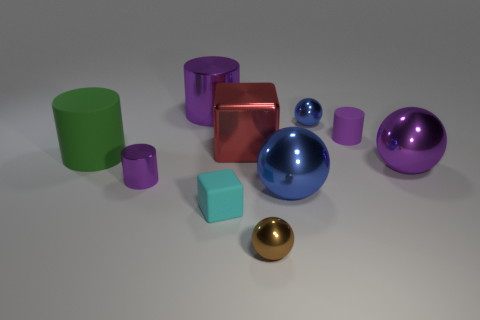There is a matte cylinder on the right side of the big blue thing; does it have the same color as the tiny metal cylinder?
Ensure brevity in your answer.  Yes. Do the brown metallic thing and the purple ball have the same size?
Your response must be concise. No. What number of matte objects are the same size as the green matte cylinder?
Make the answer very short. 0. What shape is the small object that is the same color as the small matte cylinder?
Keep it short and to the point. Cylinder. Do the large ball to the right of the large blue thing and the large green cylinder that is to the left of the red metal cube have the same material?
Your answer should be very brief. No. What is the color of the large block?
Your answer should be very brief. Red. How many red matte objects are the same shape as the big blue metallic object?
Your response must be concise. 0. What is the color of the metallic cube that is the same size as the green rubber object?
Keep it short and to the point. Red. Are there any small green matte cylinders?
Keep it short and to the point. No. What is the shape of the tiny purple thing that is in front of the green cylinder?
Provide a short and direct response. Cylinder. 